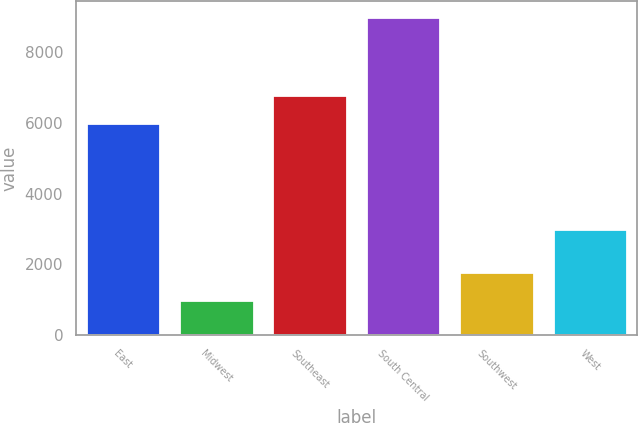Convert chart. <chart><loc_0><loc_0><loc_500><loc_500><bar_chart><fcel>East<fcel>Midwest<fcel>Southeast<fcel>South Central<fcel>Southwest<fcel>West<nl><fcel>6000<fcel>1000<fcel>6800<fcel>9000<fcel>1800<fcel>3000<nl></chart> 